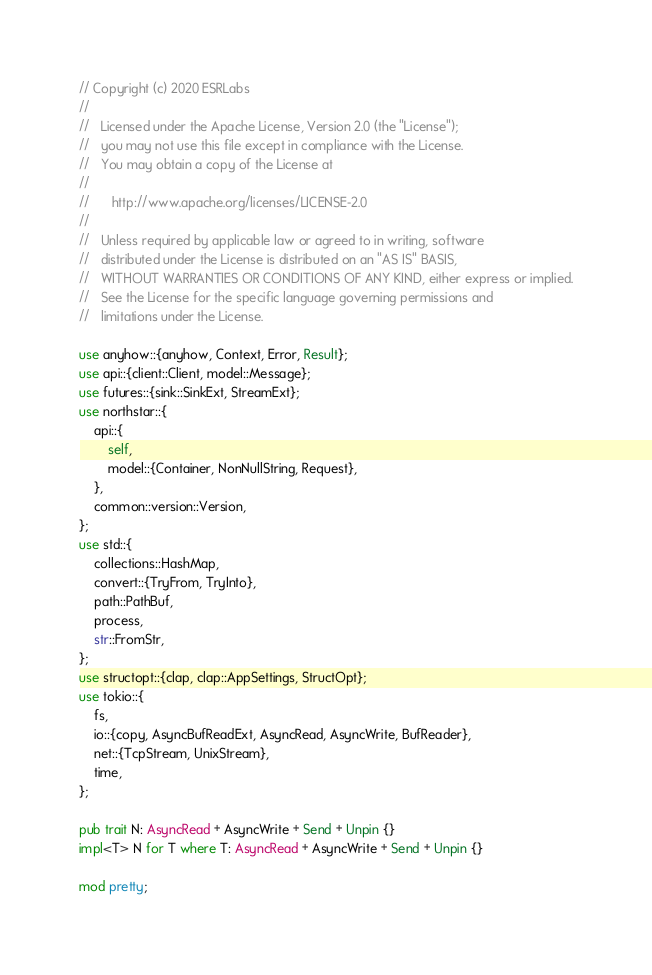<code> <loc_0><loc_0><loc_500><loc_500><_Rust_>// Copyright (c) 2020 ESRLabs
//
//   Licensed under the Apache License, Version 2.0 (the "License");
//   you may not use this file except in compliance with the License.
//   You may obtain a copy of the License at
//
//      http://www.apache.org/licenses/LICENSE-2.0
//
//   Unless required by applicable law or agreed to in writing, software
//   distributed under the License is distributed on an "AS IS" BASIS,
//   WITHOUT WARRANTIES OR CONDITIONS OF ANY KIND, either express or implied.
//   See the License for the specific language governing permissions and
//   limitations under the License.

use anyhow::{anyhow, Context, Error, Result};
use api::{client::Client, model::Message};
use futures::{sink::SinkExt, StreamExt};
use northstar::{
    api::{
        self,
        model::{Container, NonNullString, Request},
    },
    common::version::Version,
};
use std::{
    collections::HashMap,
    convert::{TryFrom, TryInto},
    path::PathBuf,
    process,
    str::FromStr,
};
use structopt::{clap, clap::AppSettings, StructOpt};
use tokio::{
    fs,
    io::{copy, AsyncBufReadExt, AsyncRead, AsyncWrite, BufReader},
    net::{TcpStream, UnixStream},
    time,
};

pub trait N: AsyncRead + AsyncWrite + Send + Unpin {}
impl<T> N for T where T: AsyncRead + AsyncWrite + Send + Unpin {}

mod pretty;
</code> 